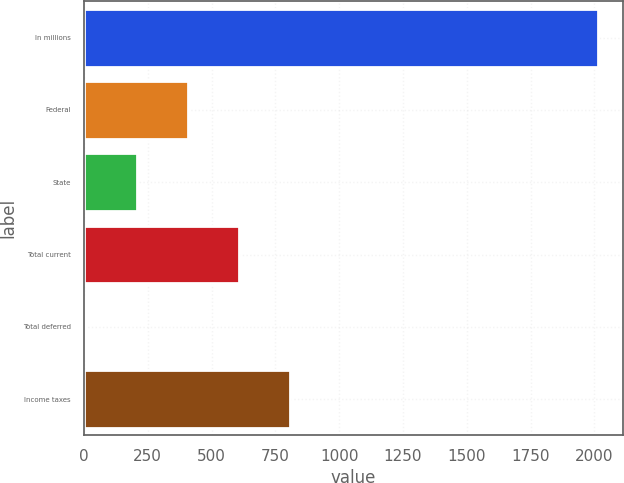<chart> <loc_0><loc_0><loc_500><loc_500><bar_chart><fcel>In millions<fcel>Federal<fcel>State<fcel>Total current<fcel>Total deferred<fcel>Income taxes<nl><fcel>2013<fcel>406.84<fcel>206.07<fcel>607.61<fcel>5.3<fcel>808.38<nl></chart> 